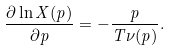Convert formula to latex. <formula><loc_0><loc_0><loc_500><loc_500>\frac { \partial \ln X ( p ) } { \partial p } = - \frac { p } { T \nu ( p ) } .</formula> 